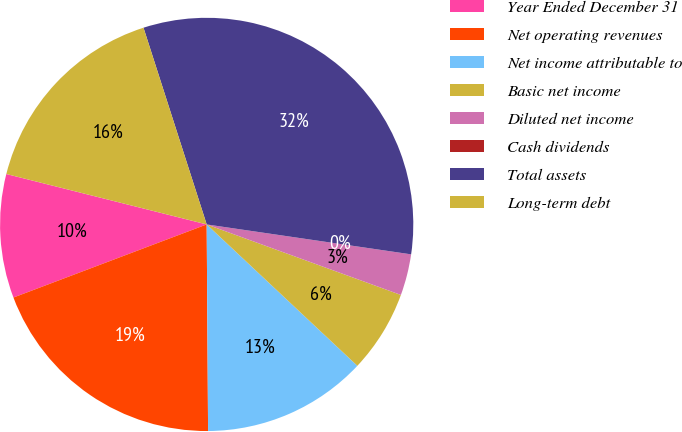Convert chart. <chart><loc_0><loc_0><loc_500><loc_500><pie_chart><fcel>Year Ended December 31<fcel>Net operating revenues<fcel>Net income attributable to<fcel>Basic net income<fcel>Diluted net income<fcel>Cash dividends<fcel>Total assets<fcel>Long-term debt<nl><fcel>9.68%<fcel>19.35%<fcel>12.9%<fcel>6.45%<fcel>3.23%<fcel>0.0%<fcel>32.26%<fcel>16.13%<nl></chart> 